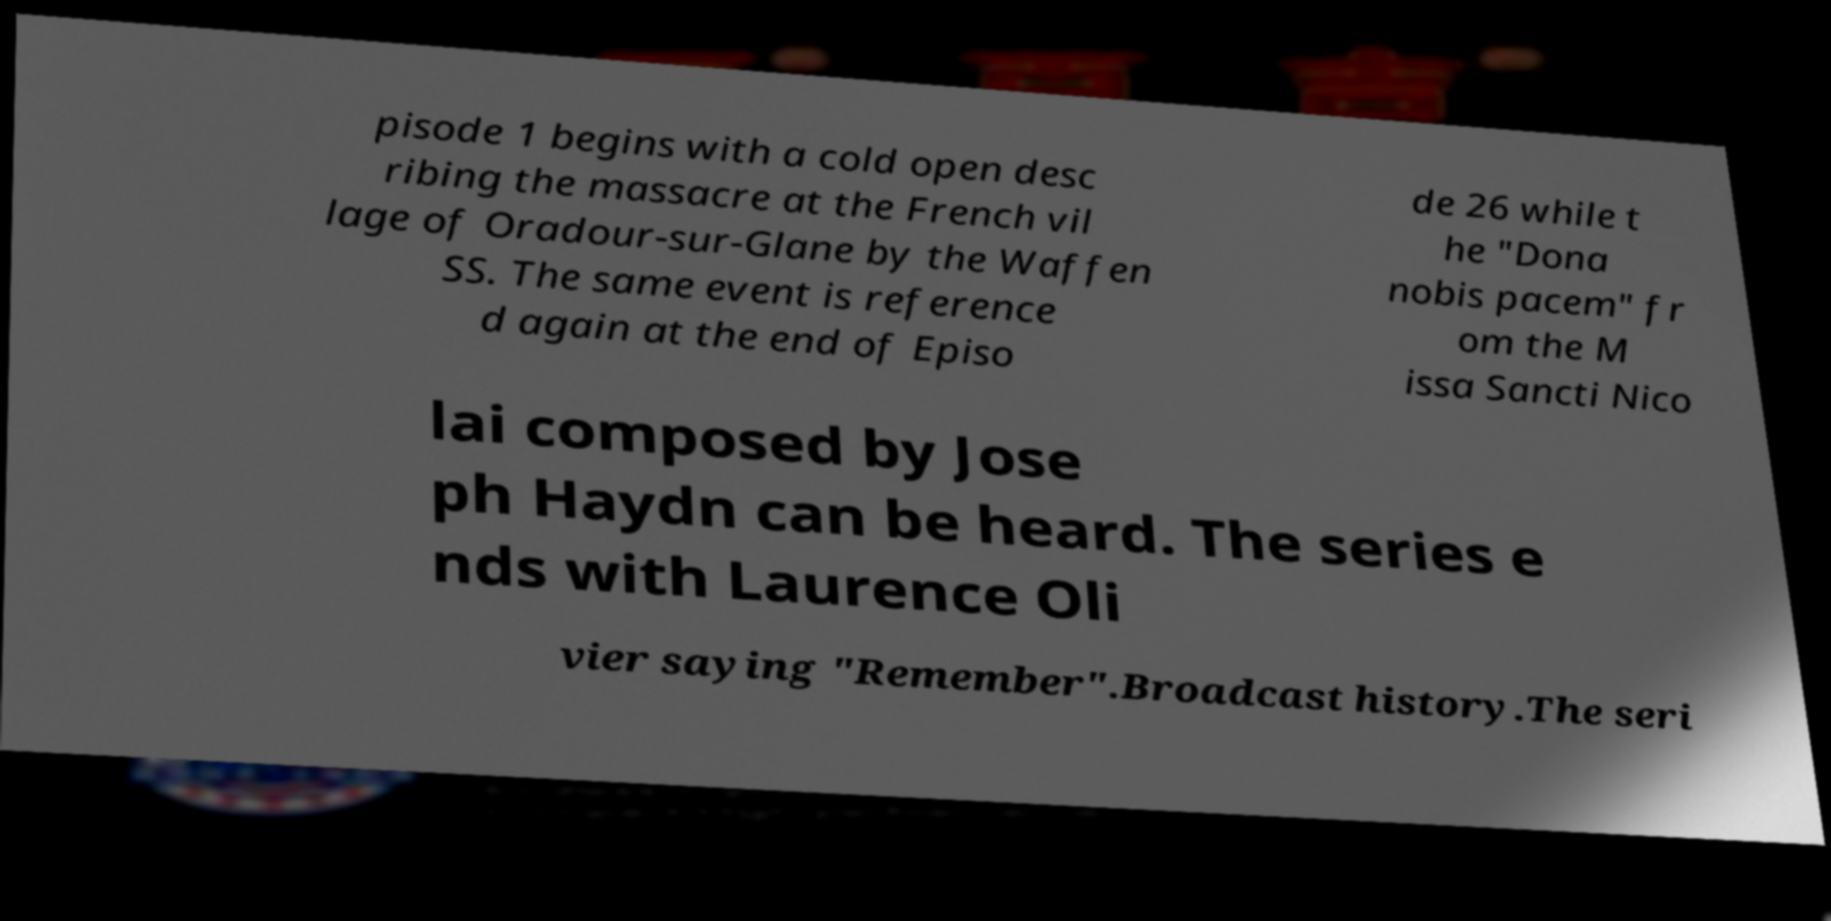I need the written content from this picture converted into text. Can you do that? pisode 1 begins with a cold open desc ribing the massacre at the French vil lage of Oradour-sur-Glane by the Waffen SS. The same event is reference d again at the end of Episo de 26 while t he "Dona nobis pacem" fr om the M issa Sancti Nico lai composed by Jose ph Haydn can be heard. The series e nds with Laurence Oli vier saying "Remember".Broadcast history.The seri 